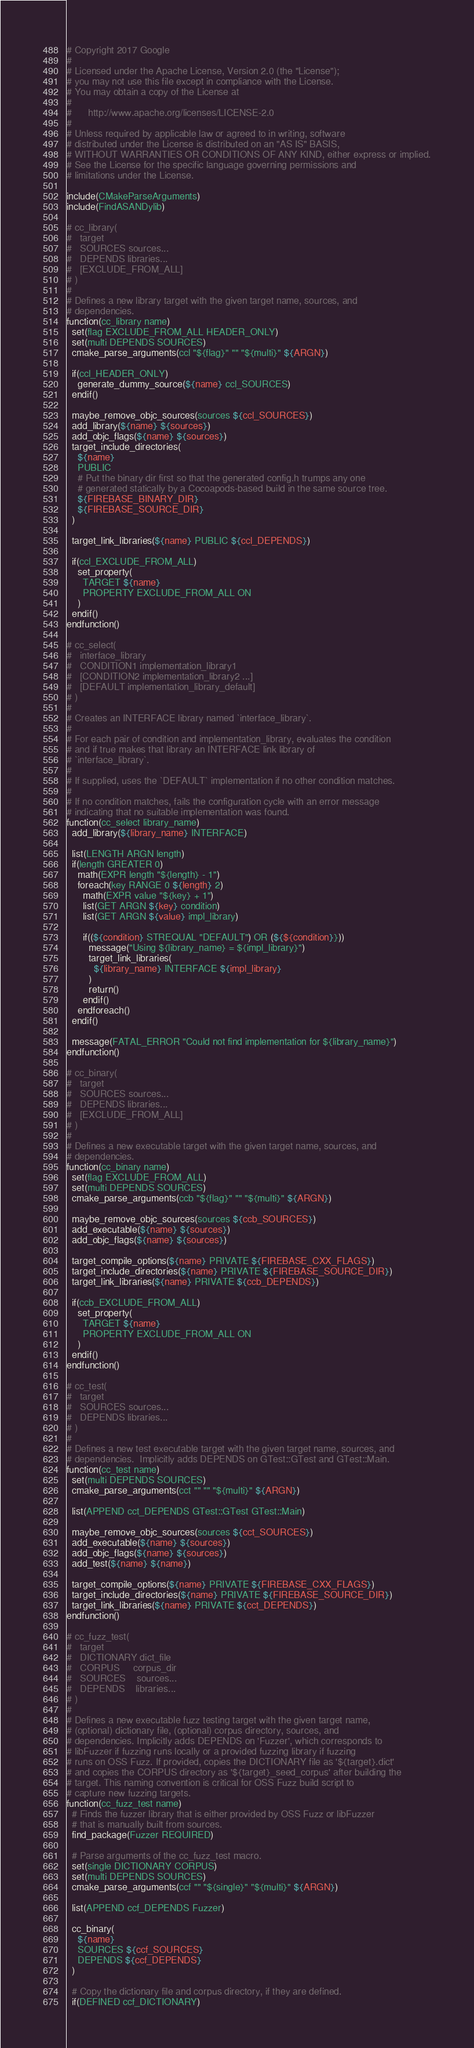<code> <loc_0><loc_0><loc_500><loc_500><_CMake_># Copyright 2017 Google
#
# Licensed under the Apache License, Version 2.0 (the "License");
# you may not use this file except in compliance with the License.
# You may obtain a copy of the License at
#
#      http://www.apache.org/licenses/LICENSE-2.0
#
# Unless required by applicable law or agreed to in writing, software
# distributed under the License is distributed on an "AS IS" BASIS,
# WITHOUT WARRANTIES OR CONDITIONS OF ANY KIND, either express or implied.
# See the License for the specific language governing permissions and
# limitations under the License.

include(CMakeParseArguments)
include(FindASANDylib)

# cc_library(
#   target
#   SOURCES sources...
#   DEPENDS libraries...
#   [EXCLUDE_FROM_ALL]
# )
#
# Defines a new library target with the given target name, sources, and
# dependencies.
function(cc_library name)
  set(flag EXCLUDE_FROM_ALL HEADER_ONLY)
  set(multi DEPENDS SOURCES)
  cmake_parse_arguments(ccl "${flag}" "" "${multi}" ${ARGN})

  if(ccl_HEADER_ONLY)
    generate_dummy_source(${name} ccl_SOURCES)
  endif()

  maybe_remove_objc_sources(sources ${ccl_SOURCES})
  add_library(${name} ${sources})
  add_objc_flags(${name} ${sources})
  target_include_directories(
    ${name}
    PUBLIC
    # Put the binary dir first so that the generated config.h trumps any one
    # generated statically by a Cocoapods-based build in the same source tree.
    ${FIREBASE_BINARY_DIR}
    ${FIREBASE_SOURCE_DIR}
  )

  target_link_libraries(${name} PUBLIC ${ccl_DEPENDS})

  if(ccl_EXCLUDE_FROM_ALL)
    set_property(
      TARGET ${name}
      PROPERTY EXCLUDE_FROM_ALL ON
    )
  endif()
endfunction()

# cc_select(
#   interface_library
#   CONDITION1 implementation_library1
#   [CONDITION2 implementation_library2 ...]
#   [DEFAULT implementation_library_default]
# )
#
# Creates an INTERFACE library named `interface_library`.
#
# For each pair of condition and implementation_library, evaluates the condition
# and if true makes that library an INTERFACE link library of
# `interface_library`.
#
# If supplied, uses the `DEFAULT` implementation if no other condition matches.
#
# If no condition matches, fails the configuration cycle with an error message
# indicating that no suitable implementation was found.
function(cc_select library_name)
  add_library(${library_name} INTERFACE)

  list(LENGTH ARGN length)
  if(length GREATER 0)
    math(EXPR length "${length} - 1")
    foreach(key RANGE 0 ${length} 2)
      math(EXPR value "${key} + 1")
      list(GET ARGN ${key} condition)
      list(GET ARGN ${value} impl_library)

      if((${condition} STREQUAL "DEFAULT") OR (${${condition}}))
        message("Using ${library_name} = ${impl_library}")
        target_link_libraries(
          ${library_name} INTERFACE ${impl_library}
        )
        return()
      endif()
    endforeach()
  endif()

  message(FATAL_ERROR "Could not find implementation for ${library_name}")
endfunction()

# cc_binary(
#   target
#   SOURCES sources...
#   DEPENDS libraries...
#   [EXCLUDE_FROM_ALL]
# )
#
# Defines a new executable target with the given target name, sources, and
# dependencies.
function(cc_binary name)
  set(flag EXCLUDE_FROM_ALL)
  set(multi DEPENDS SOURCES)
  cmake_parse_arguments(ccb "${flag}" "" "${multi}" ${ARGN})

  maybe_remove_objc_sources(sources ${ccb_SOURCES})
  add_executable(${name} ${sources})
  add_objc_flags(${name} ${sources})

  target_compile_options(${name} PRIVATE ${FIREBASE_CXX_FLAGS})
  target_include_directories(${name} PRIVATE ${FIREBASE_SOURCE_DIR})
  target_link_libraries(${name} PRIVATE ${ccb_DEPENDS})

  if(ccb_EXCLUDE_FROM_ALL)
    set_property(
      TARGET ${name}
      PROPERTY EXCLUDE_FROM_ALL ON
    )
  endif()
endfunction()

# cc_test(
#   target
#   SOURCES sources...
#   DEPENDS libraries...
# )
#
# Defines a new test executable target with the given target name, sources, and
# dependencies.  Implicitly adds DEPENDS on GTest::GTest and GTest::Main.
function(cc_test name)
  set(multi DEPENDS SOURCES)
  cmake_parse_arguments(cct "" "" "${multi}" ${ARGN})

  list(APPEND cct_DEPENDS GTest::GTest GTest::Main)

  maybe_remove_objc_sources(sources ${cct_SOURCES})
  add_executable(${name} ${sources})
  add_objc_flags(${name} ${sources})
  add_test(${name} ${name})

  target_compile_options(${name} PRIVATE ${FIREBASE_CXX_FLAGS})
  target_include_directories(${name} PRIVATE ${FIREBASE_SOURCE_DIR})
  target_link_libraries(${name} PRIVATE ${cct_DEPENDS})
endfunction()

# cc_fuzz_test(
#   target
#   DICTIONARY dict_file
#   CORPUS     corpus_dir
#   SOURCES    sources...
#   DEPENDS    libraries...
# )
#
# Defines a new executable fuzz testing target with the given target name,
# (optional) dictionary file, (optional) corpus directory, sources, and
# dependencies. Implicitly adds DEPENDS on 'Fuzzer', which corresponds to
# libFuzzer if fuzzing runs locally or a provided fuzzing library if fuzzing
# runs on OSS Fuzz. If provided, copies the DICTIONARY file as '${target}.dict'
# and copies the CORPUS directory as '${target}_seed_corpus' after building the
# target. This naming convention is critical for OSS Fuzz build script to
# capture new fuzzing targets.
function(cc_fuzz_test name)
  # Finds the fuzzer library that is either provided by OSS Fuzz or libFuzzer
  # that is manually built from sources.
  find_package(Fuzzer REQUIRED)

  # Parse arguments of the cc_fuzz_test macro.
  set(single DICTIONARY CORPUS)
  set(multi DEPENDS SOURCES)
  cmake_parse_arguments(ccf "" "${single}" "${multi}" ${ARGN})

  list(APPEND ccf_DEPENDS Fuzzer)

  cc_binary(
    ${name}
    SOURCES ${ccf_SOURCES}
    DEPENDS ${ccf_DEPENDS}
  )

  # Copy the dictionary file and corpus directory, if they are defined.
  if(DEFINED ccf_DICTIONARY)</code> 